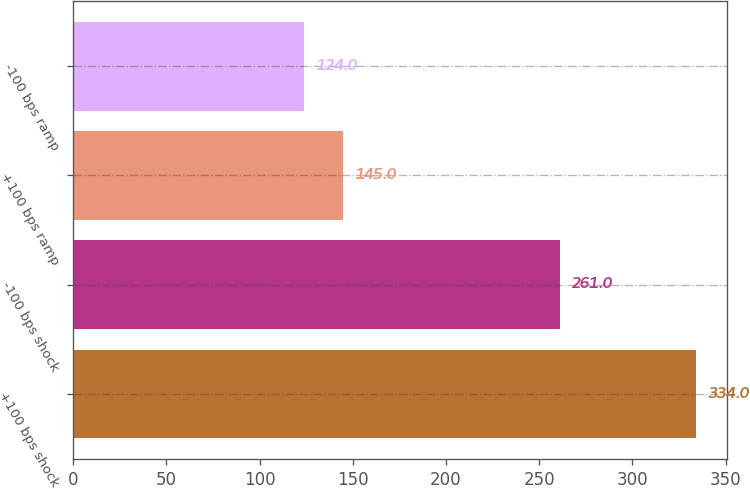<chart> <loc_0><loc_0><loc_500><loc_500><bar_chart><fcel>+100 bps shock<fcel>-100 bps shock<fcel>+100 bps ramp<fcel>-100 bps ramp<nl><fcel>334<fcel>261<fcel>145<fcel>124<nl></chart> 